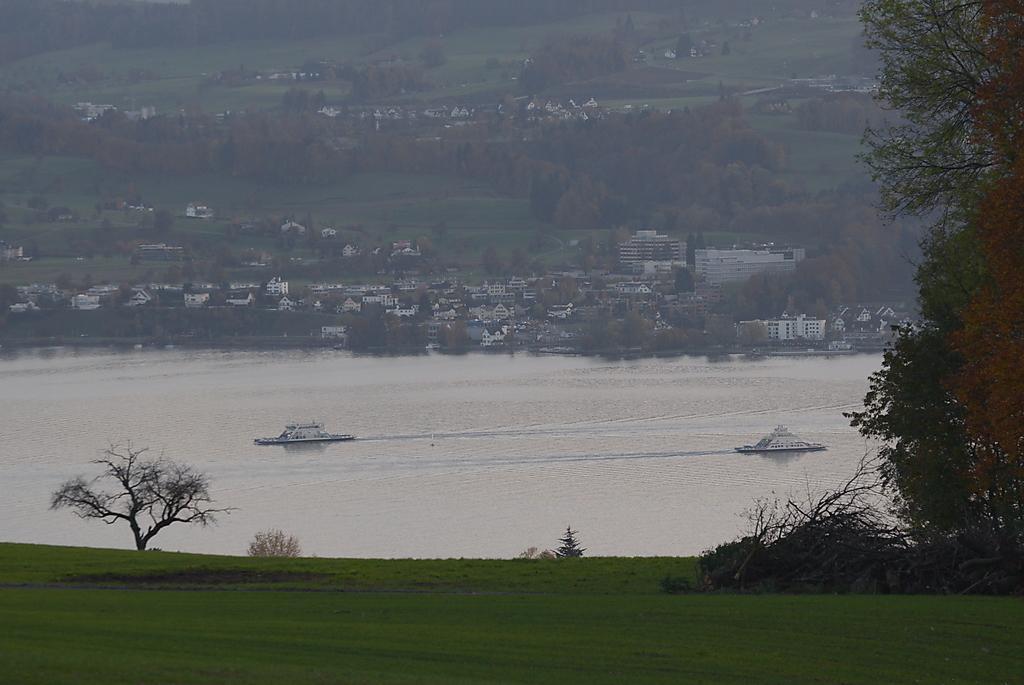Can you describe this image briefly? This picture is clicked outside the city. In the foreground we can see the green grass, trees and plants. In the center we can the ships in the water body. In the background we can see the buildings, trees, plants and the green grass and some other objects. 